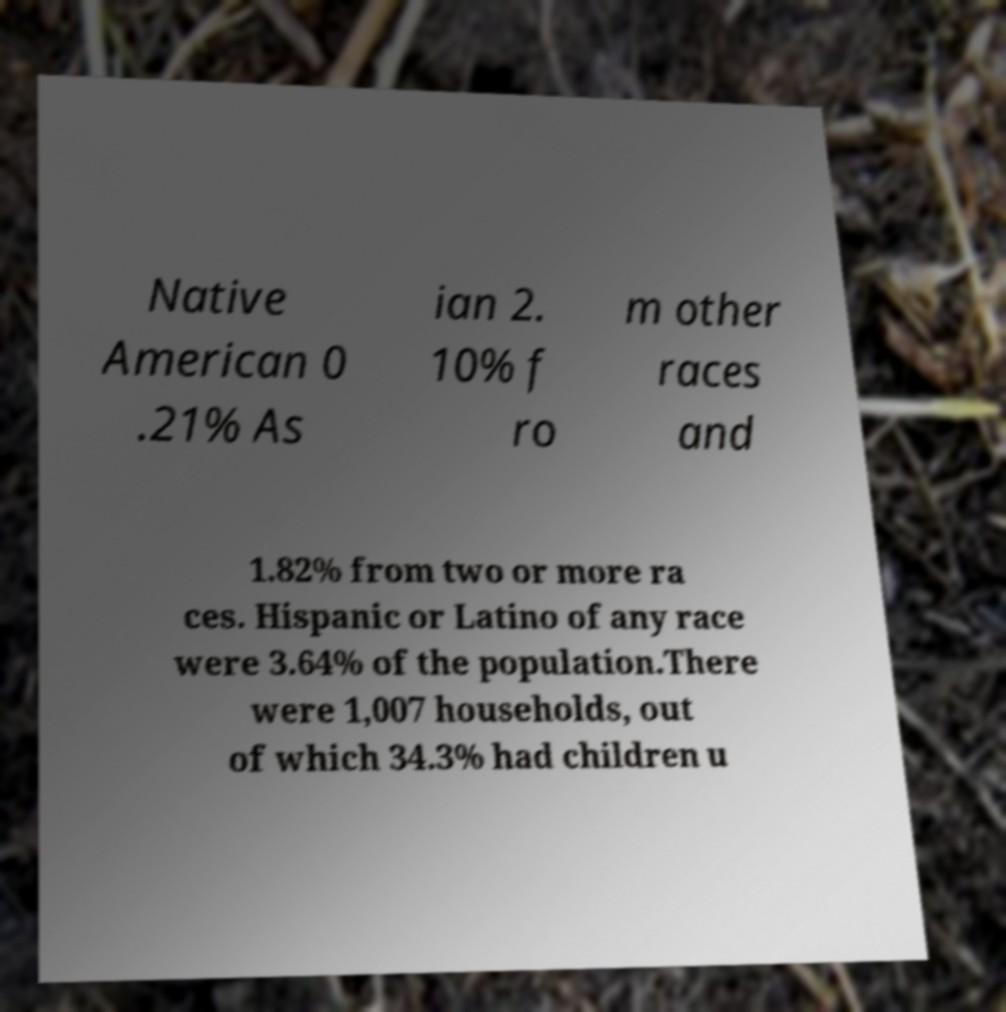Could you assist in decoding the text presented in this image and type it out clearly? Native American 0 .21% As ian 2. 10% f ro m other races and 1.82% from two or more ra ces. Hispanic or Latino of any race were 3.64% of the population.There were 1,007 households, out of which 34.3% had children u 